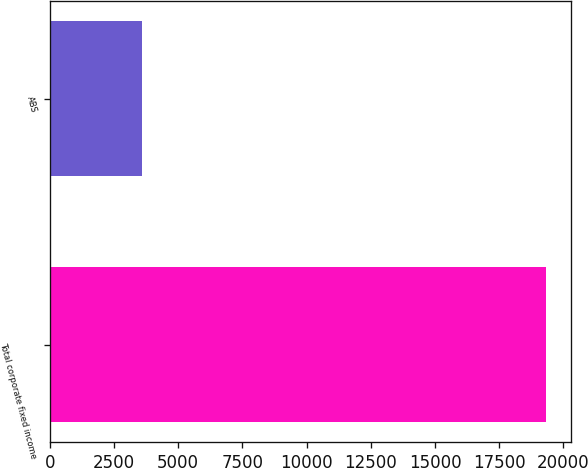<chart> <loc_0><loc_0><loc_500><loc_500><bar_chart><fcel>Total corporate fixed income<fcel>ABS<nl><fcel>19330<fcel>3595<nl></chart> 